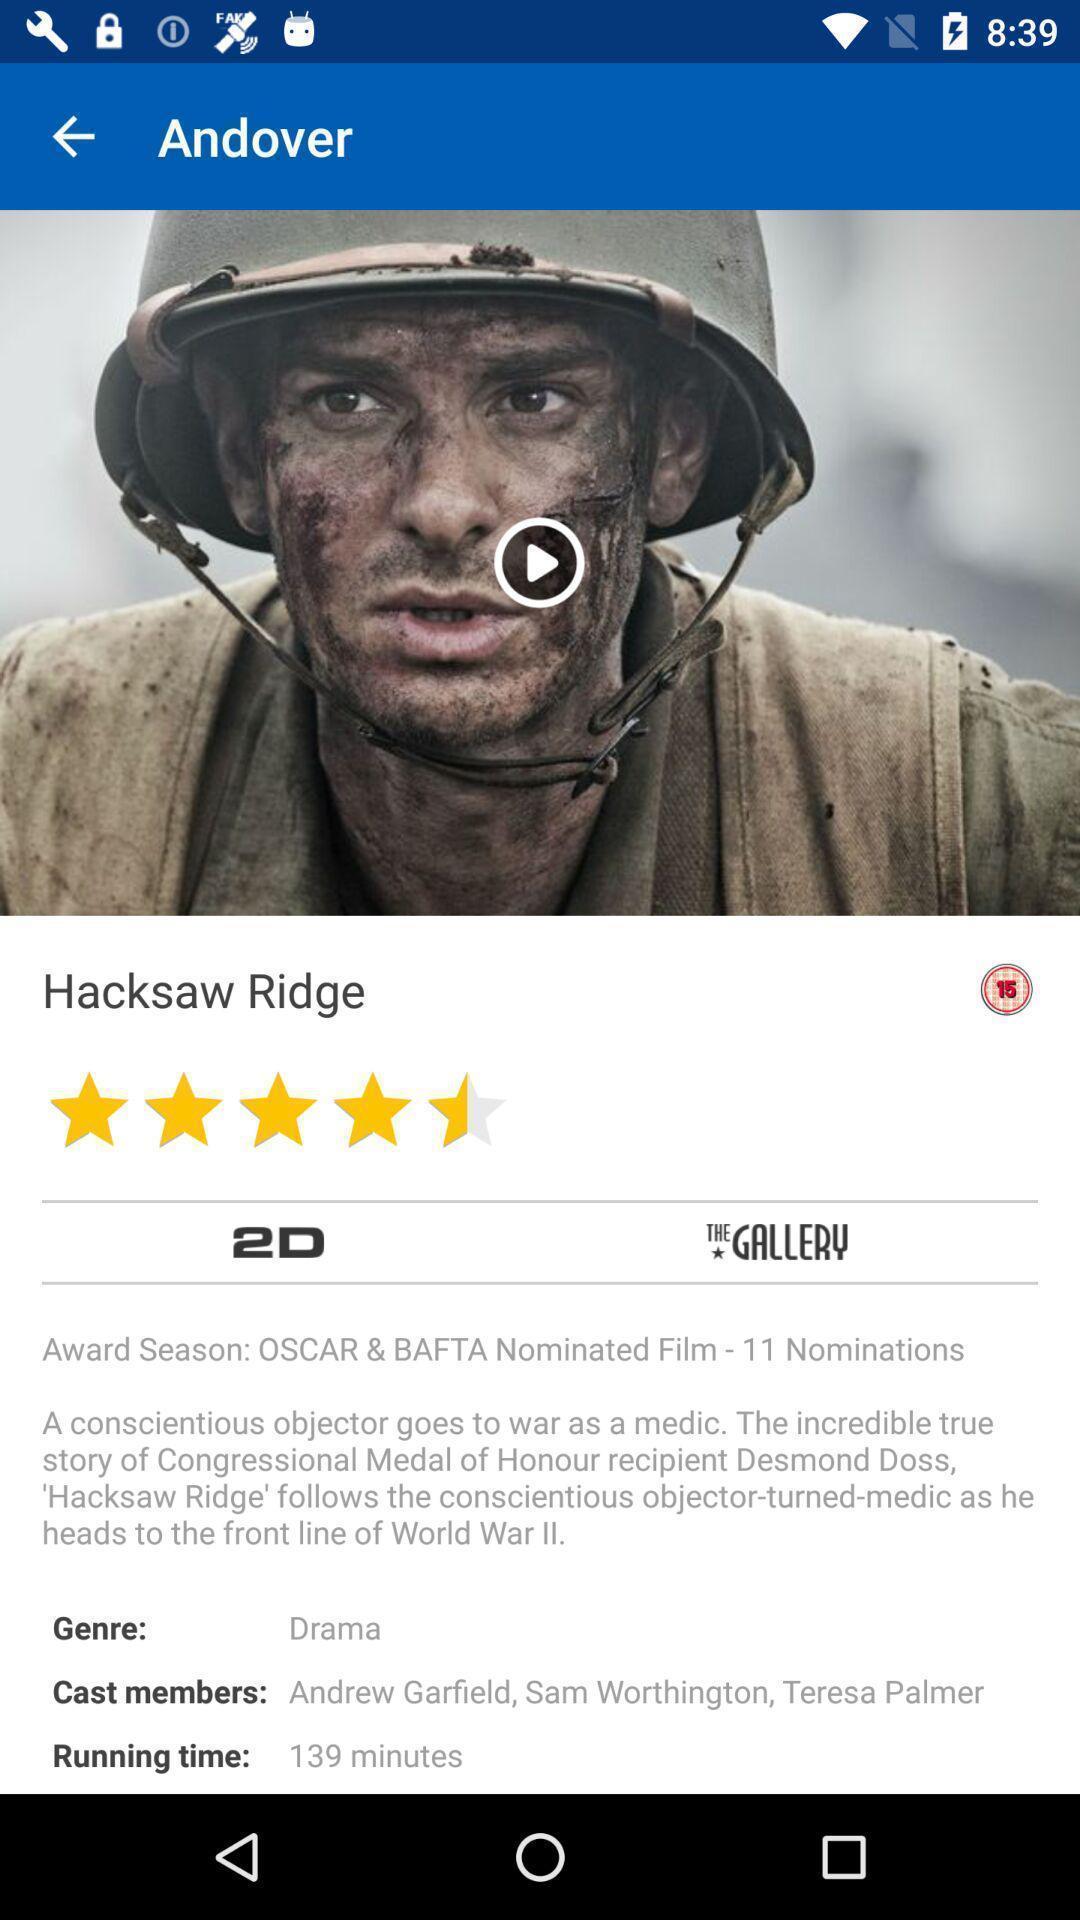Describe the content in this image. Screen shows about movie description in the application. 